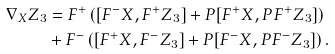Convert formula to latex. <formula><loc_0><loc_0><loc_500><loc_500>\nabla _ { X } Z _ { 3 } & = F ^ { + } \left ( [ F ^ { - } X , F ^ { + } Z _ { 3 } ] + P [ F ^ { + } X , P F ^ { + } Z _ { 3 } ] \right ) \\ & + F ^ { - } \left ( [ F ^ { + } X , F ^ { - } Z _ { 3 } ] + P [ F ^ { - } X , P F ^ { - } Z _ { 3 } ] \right ) .</formula> 